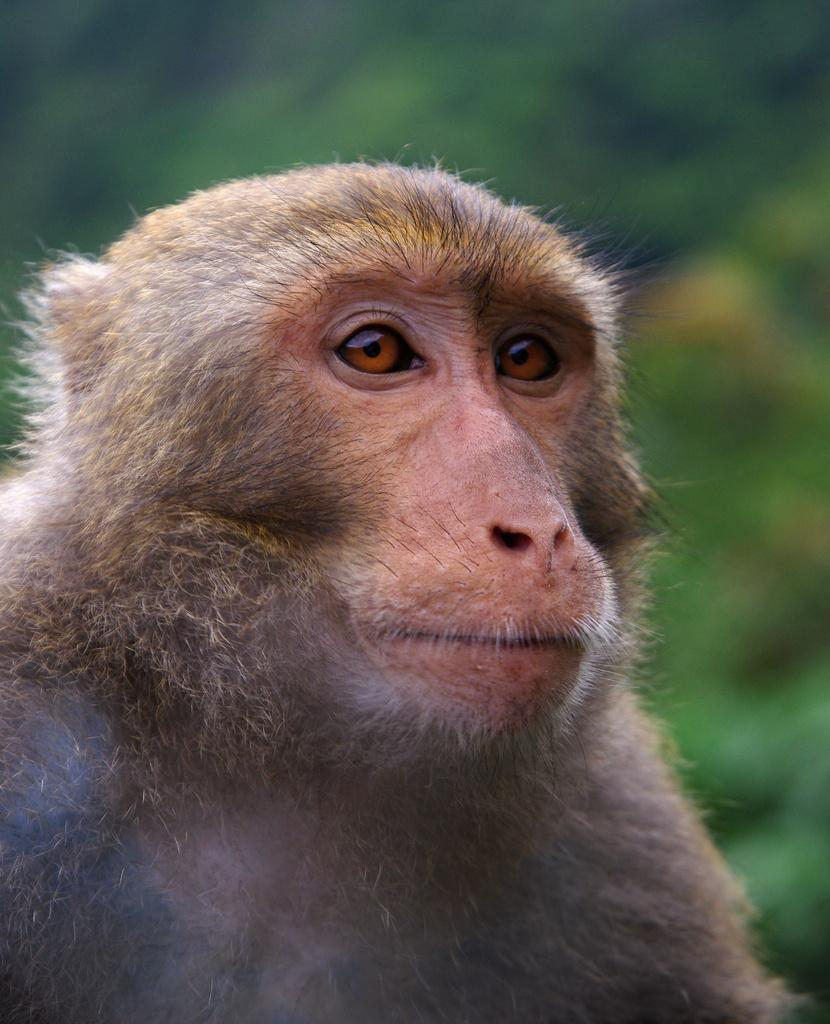What is the main subject in the foreground of the image? There is a monkey in the foreground of the image. Can you describe the background of the image? The background of the image is blurred. What type of sofa can be seen in the image? There is no sofa present in the image. Can you tell me how many pickles are on the monkey's head in the image? There are no pickles present in the image, and therefore no such objects can be observed on the monkey's head. 